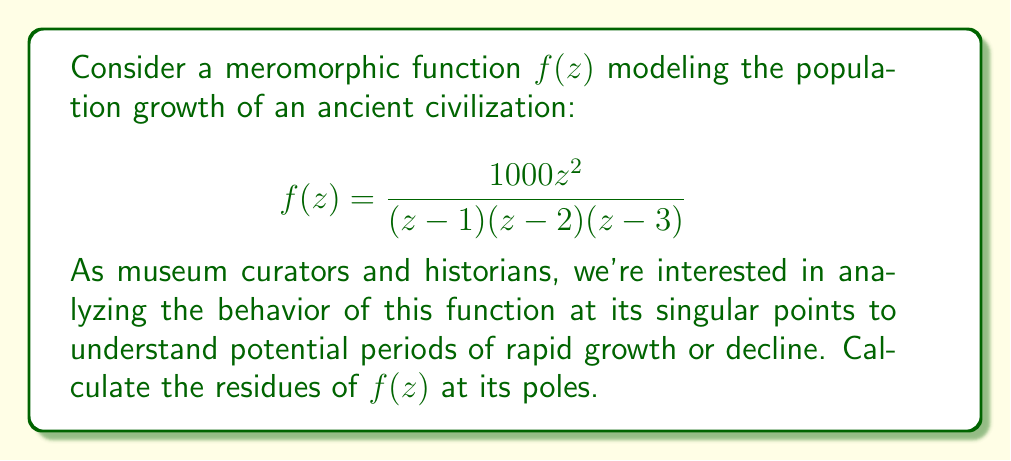Solve this math problem. To calculate the residues of the meromorphic function $f(z)$, we need to determine its poles and then compute the residue at each pole. Let's approach this step-by-step:

1) First, identify the poles of $f(z)$:
   The poles are at $z=1$, $z=2$, and $z=3$, all of which are simple poles.

2) For a simple pole at $z=a$, the residue is given by:
   $$\text{Res}(f,a) = \lim_{z \to a} (z-a)f(z)$$

3) Let's calculate the residue at each pole:

   a) At $z=1$:
      $$\begin{align*}
      \text{Res}(f,1) &= \lim_{z \to 1} (z-1)\frac{1000z^2}{(z-1)(z-2)(z-3)} \\
      &= \lim_{z \to 1} \frac{1000z^2}{(z-2)(z-3)} \\
      &= \frac{1000(1)^2}{(1-2)(1-3)} = \frac{1000}{2}
      \end{align*}$$

   b) At $z=2$:
      $$\begin{align*}
      \text{Res}(f,2) &= \lim_{z \to 2} (z-2)\frac{1000z^2}{(z-1)(z-2)(z-3)} \\
      &= \lim_{z \to 2} \frac{1000z^2}{(z-1)(z-3)} \\
      &= \frac{1000(2)^2}{(2-1)(2-3)} = -4000
      \end{align*}$$

   c) At $z=3$:
      $$\begin{align*}
      \text{Res}(f,3) &= \lim_{z \to 3} (z-3)\frac{1000z^2}{(z-1)(z-2)(z-3)} \\
      &= \lim_{z \to 3} \frac{1000z^2}{(z-1)(z-2)} \\
      &= \frac{1000(3)^2}{(3-1)(3-2)} = \frac{9000}{2}
      \end{align*}$$

These residues provide insights into the behavior of the population growth model near these critical points, which could correspond to significant historical events or periods affecting the civilization's demographics.
Answer: The residues of $f(z)$ at its poles are:

$\text{Res}(f,1) = 500$
$\text{Res}(f,2) = -4000$
$\text{Res}(f,3) = 4500$ 